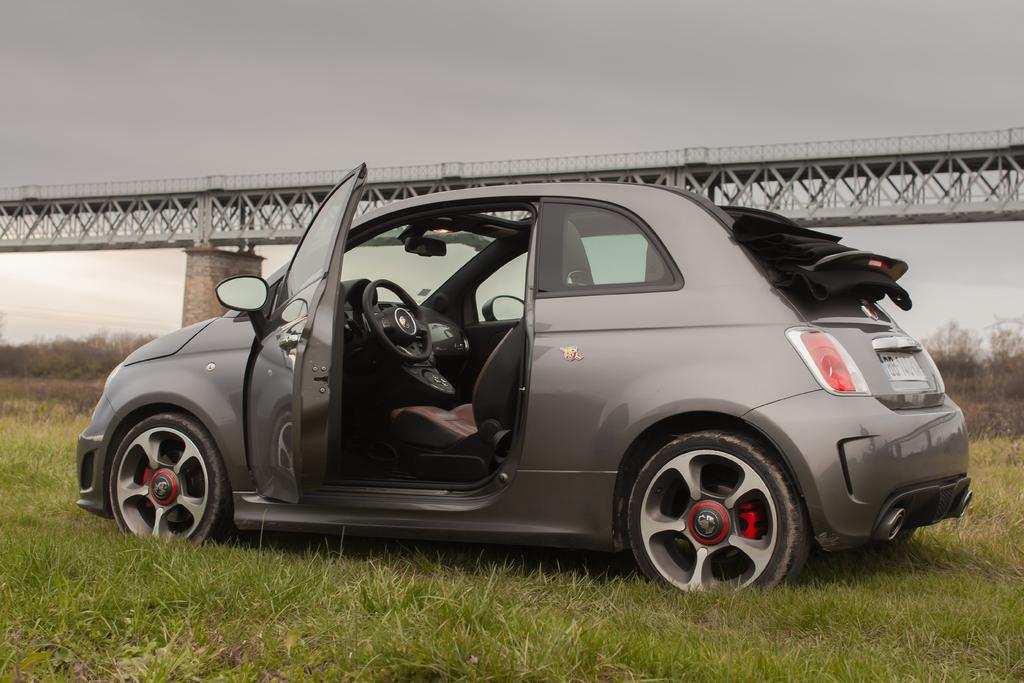What type of motor vehicle is in the image? The image contains a motor vehicle, but the specific type is not mentioned. Where is the motor vehicle located? The motor vehicle is on the grass. What can be seen on the bridge in the image? The bridge has iron grills. What is visible in the background of the image? The sky is visible in the background of the image. What type of treatment is being administered to the cannon in the image? There is no cannon present in the image, so no treatment can be administered. What is the reason for the motor vehicle being on the grass in the image? The reason for the motor vehicle being on the grass is not mentioned in the image, so we cannot determine the reason. 